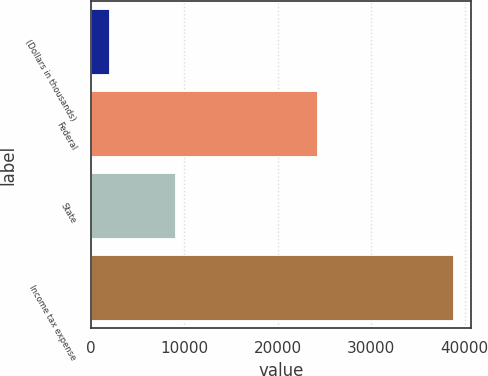Convert chart. <chart><loc_0><loc_0><loc_500><loc_500><bar_chart><fcel>(Dollars in thousands)<fcel>Federal<fcel>State<fcel>Income tax expense<nl><fcel>2004<fcel>24207<fcel>8975<fcel>38754<nl></chart> 